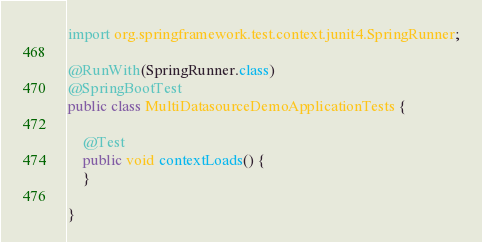Convert code to text. <code><loc_0><loc_0><loc_500><loc_500><_Java_>import org.springframework.test.context.junit4.SpringRunner;

@RunWith(SpringRunner.class)
@SpringBootTest
public class MultiDatasourceDemoApplicationTests {

    @Test
    public void contextLoads() {
    }

}
</code> 